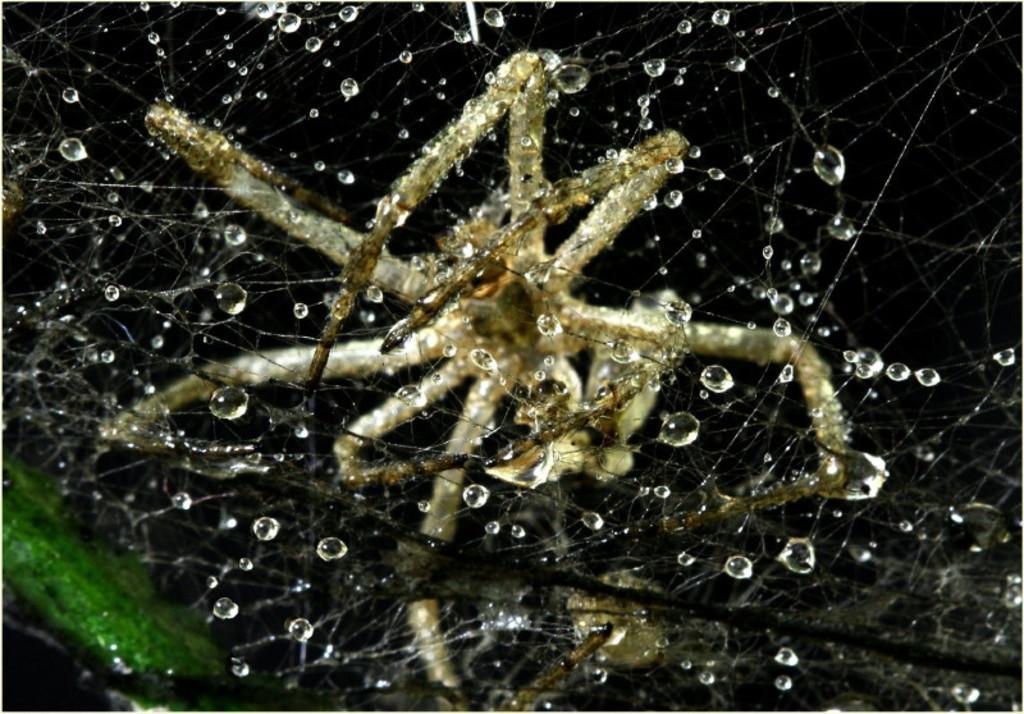How would you summarize this image in a sentence or two? In this image we can see spider in its web. 